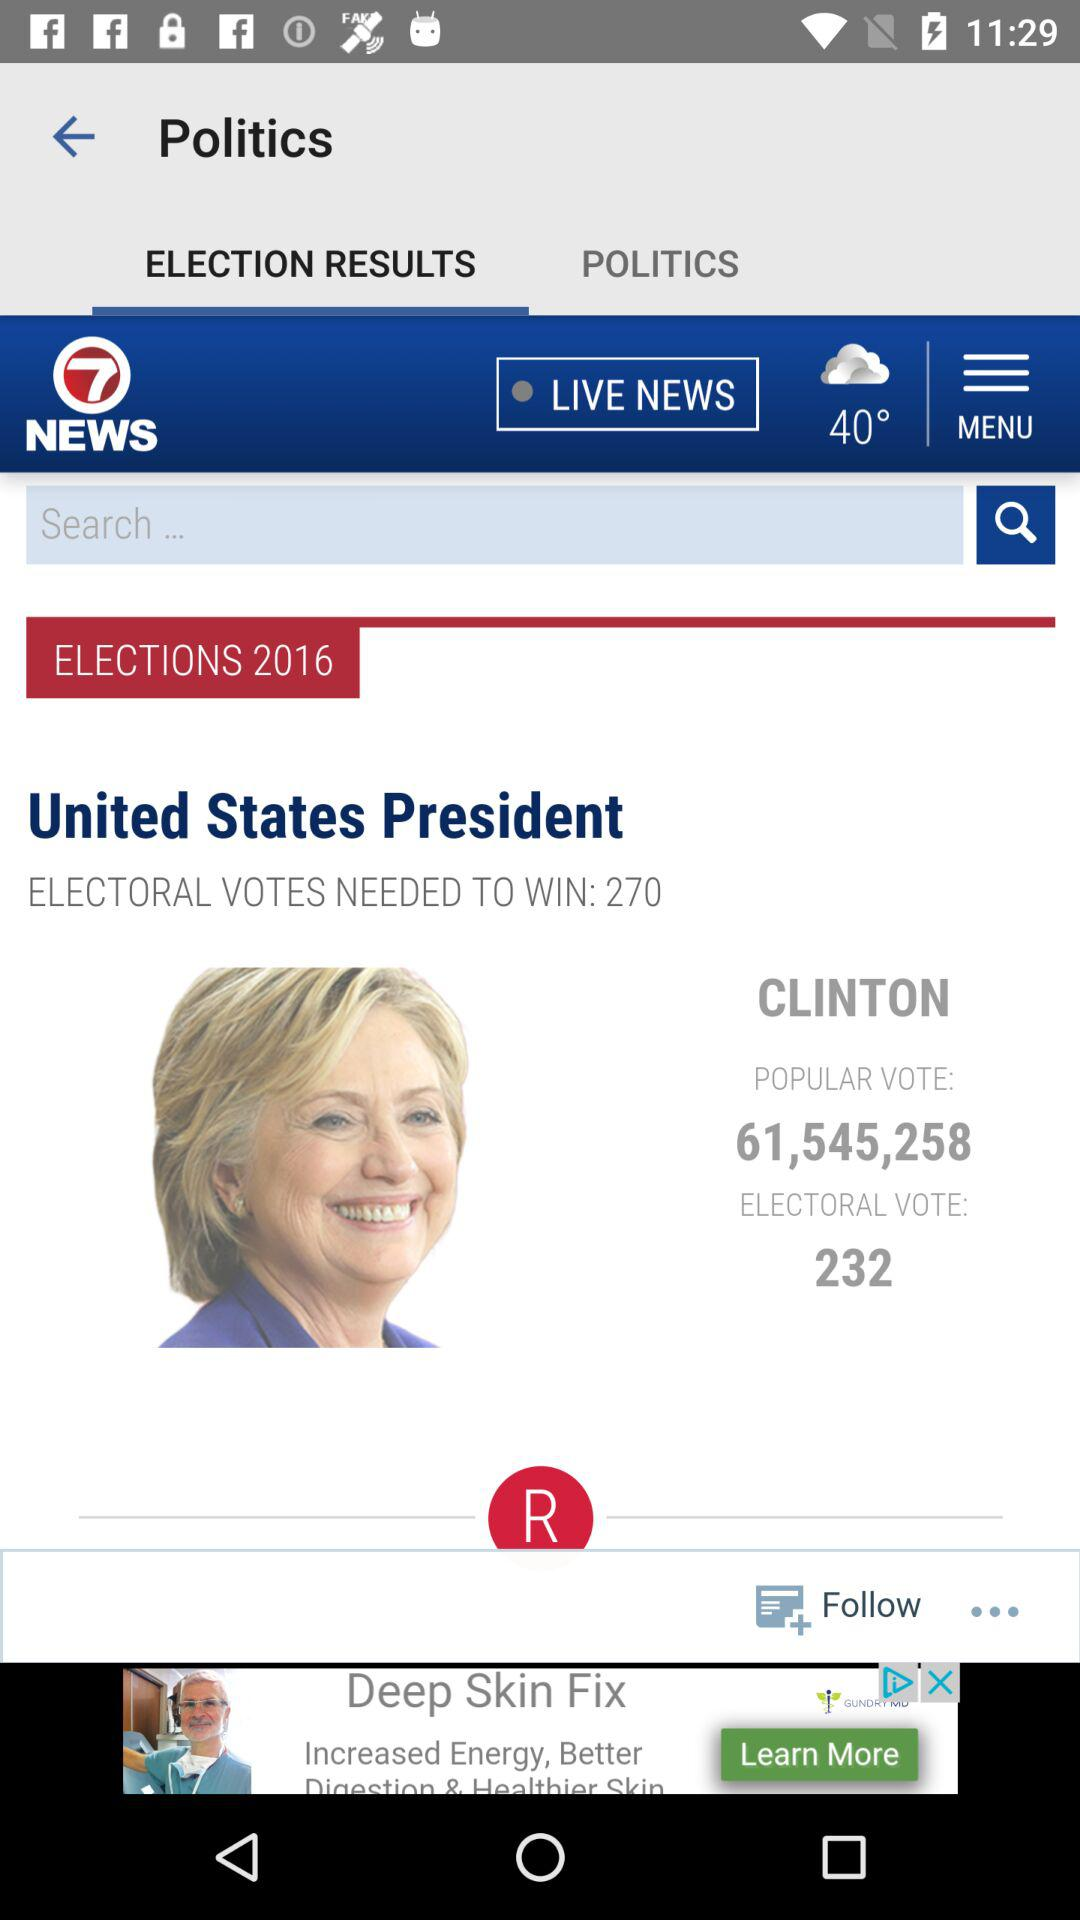What is the weather forecast? The weather is cloudy. 